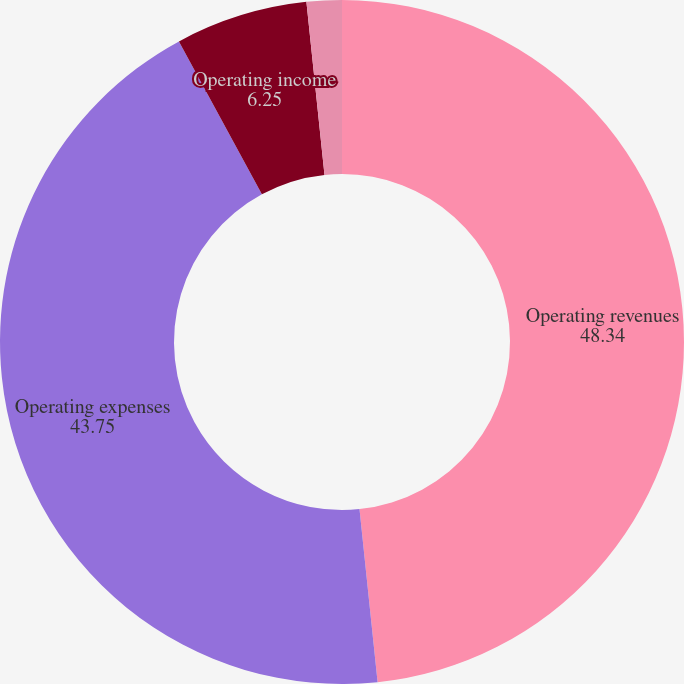<chart> <loc_0><loc_0><loc_500><loc_500><pie_chart><fcel>Operating revenues<fcel>Operating expenses<fcel>Operating income<fcel>Net income<nl><fcel>48.34%<fcel>43.75%<fcel>6.25%<fcel>1.66%<nl></chart> 